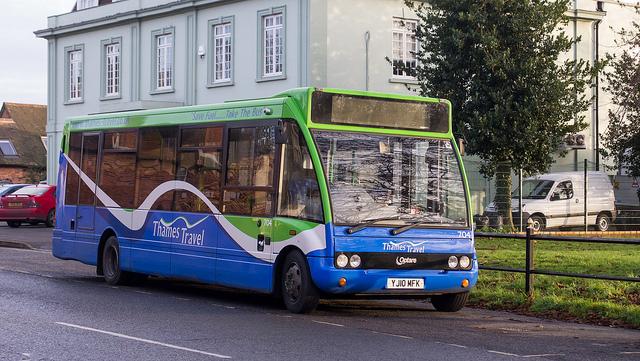Is that a brick building?
Concise answer only. No. Where is the red car?
Quick response, please. Behind bus. What three colors are painted on the bus?
Be succinct. Blue green white. Is this tour bus parked?
Concise answer only. Yes. 